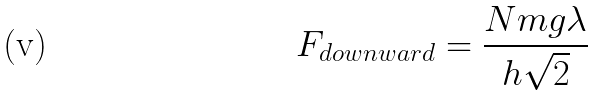<formula> <loc_0><loc_0><loc_500><loc_500>\ F _ { d o w n w a r d } = \frac { N m g \lambda } { h \sqrt { 2 } }</formula> 